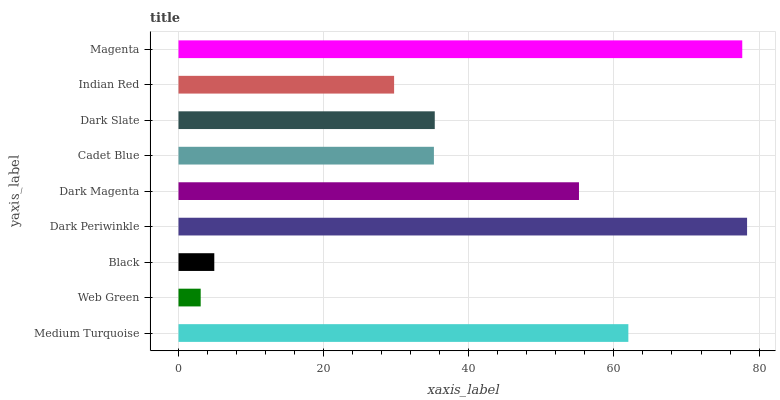Is Web Green the minimum?
Answer yes or no. Yes. Is Dark Periwinkle the maximum?
Answer yes or no. Yes. Is Black the minimum?
Answer yes or no. No. Is Black the maximum?
Answer yes or no. No. Is Black greater than Web Green?
Answer yes or no. Yes. Is Web Green less than Black?
Answer yes or no. Yes. Is Web Green greater than Black?
Answer yes or no. No. Is Black less than Web Green?
Answer yes or no. No. Is Dark Slate the high median?
Answer yes or no. Yes. Is Dark Slate the low median?
Answer yes or no. Yes. Is Magenta the high median?
Answer yes or no. No. Is Web Green the low median?
Answer yes or no. No. 